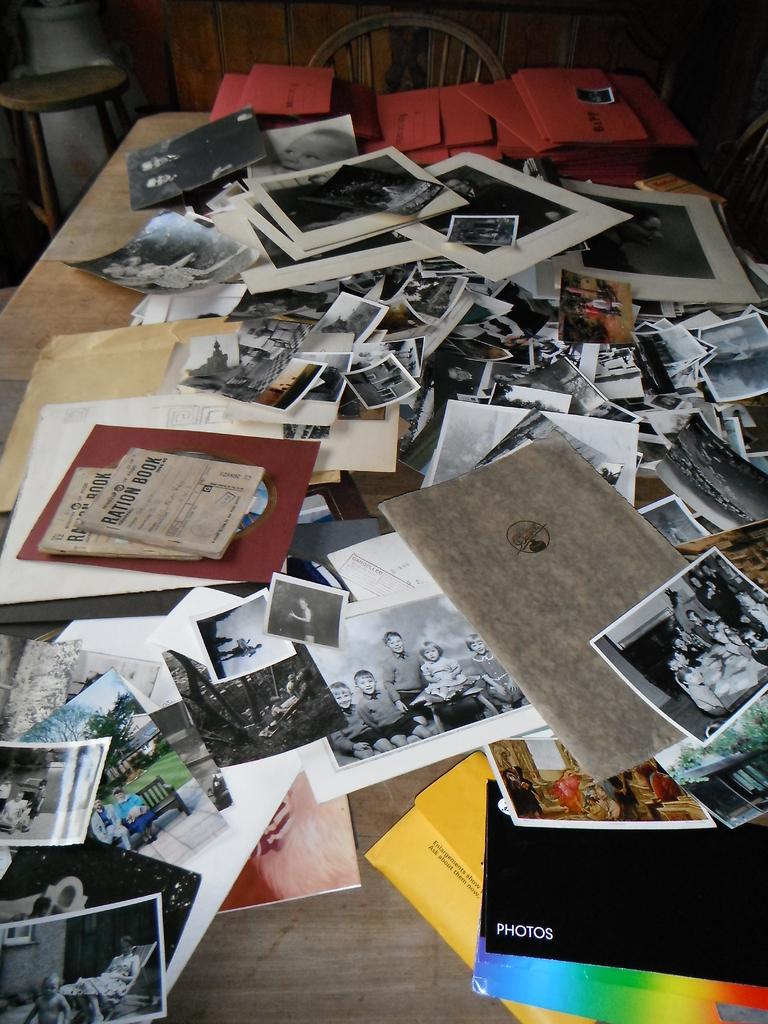What type of table is in the image? There is a wooden table in the image. What items can be seen on the table? Photos, books, papers, and files are on the table. Is there any seating behind the table? Yes, there is a stool behind the table. What else can be seen behind the table? A wheel and other objects are visible behind the table. Can you see the elbow of the person sitting on the stool in the image? There is no person sitting on the stool in the image, so it is not possible to see their elbow. 